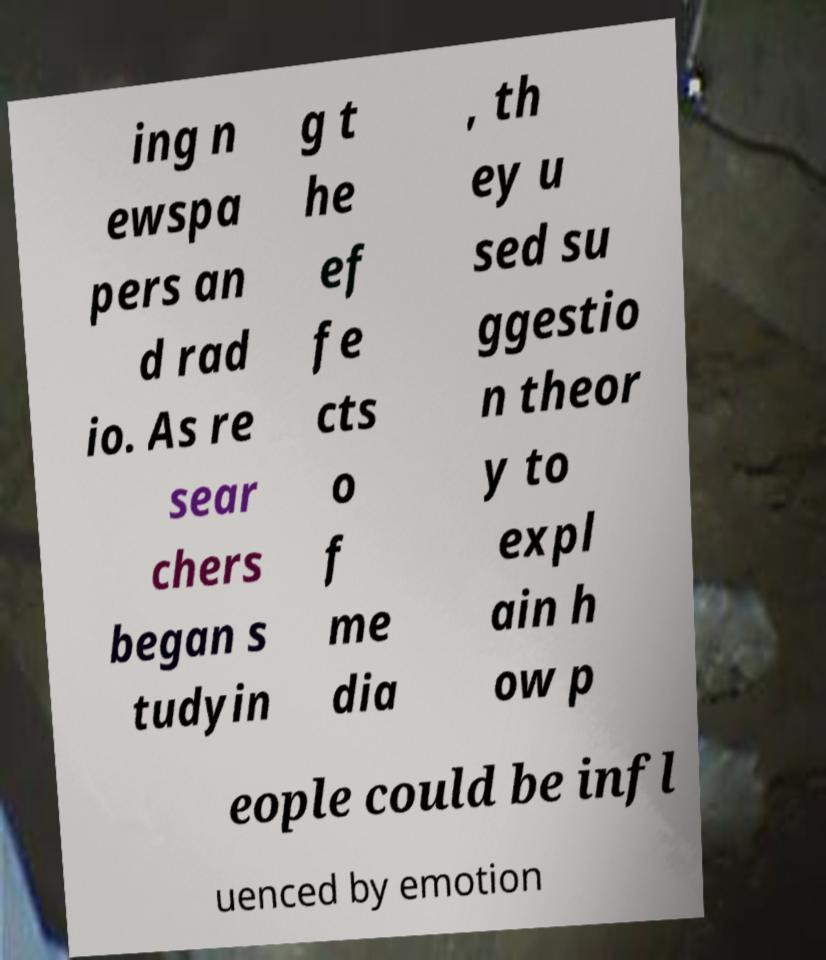Please read and relay the text visible in this image. What does it say? ing n ewspa pers an d rad io. As re sear chers began s tudyin g t he ef fe cts o f me dia , th ey u sed su ggestio n theor y to expl ain h ow p eople could be infl uenced by emotion 